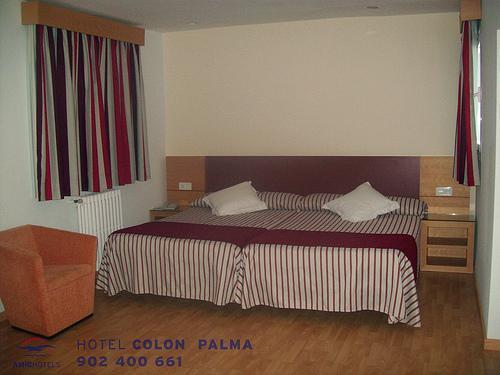How many windows are pictured?
Give a very brief answer. 2. How many chairs are there?
Give a very brief answer. 1. 